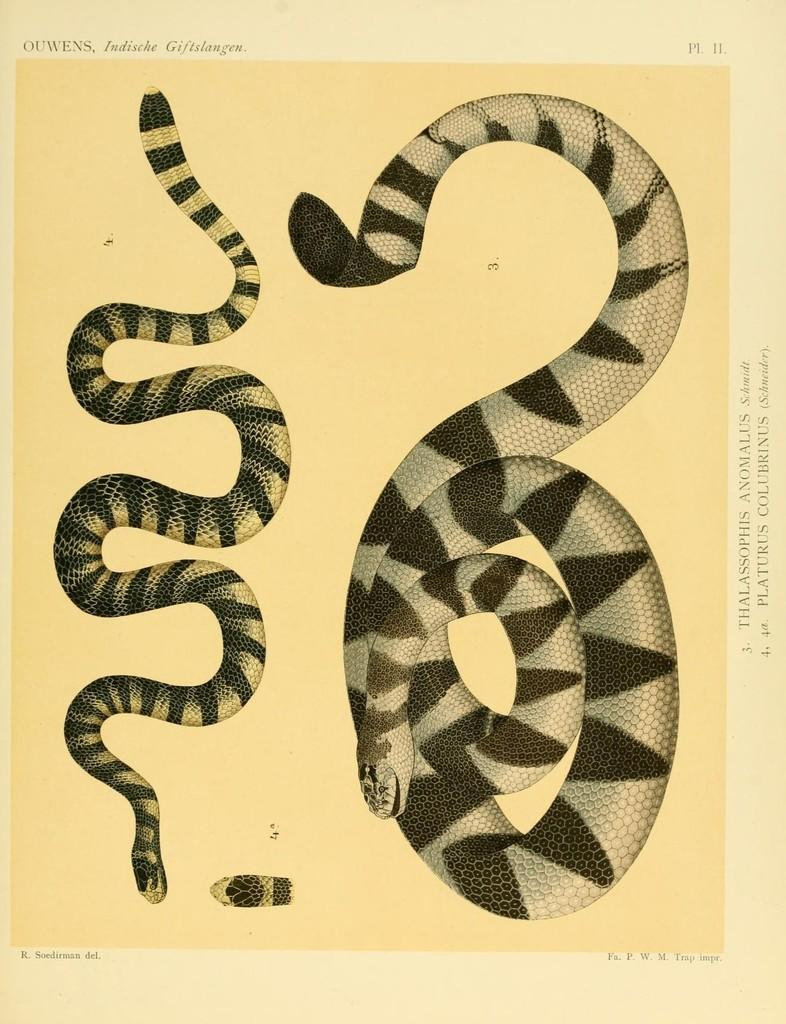What is the main object in the image? There is a paper in the image. What is depicted on the paper? There are snakes depicted on the paper. What else can be found on the paper besides the snakes? There is text and a number on the paper. What type of music can be heard playing from the square in the image? There is no square or music present in the image; it only features a paper with snakes, text, and a number. 